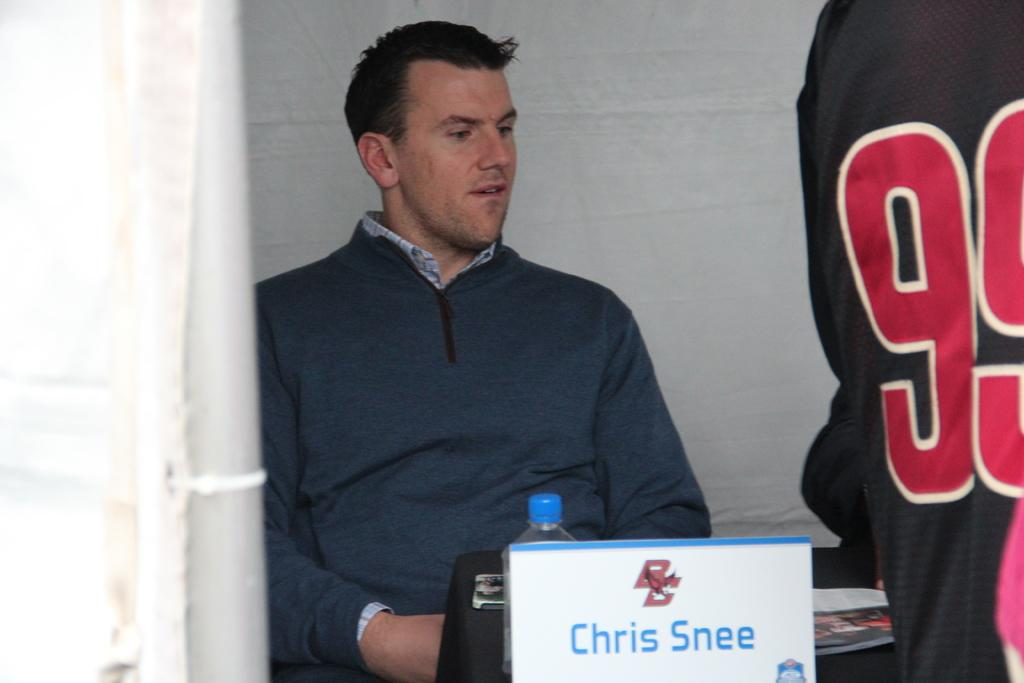<image>
Render a clear and concise summary of the photo. A sign with the name Chris Sneer on it is in front of a man. 